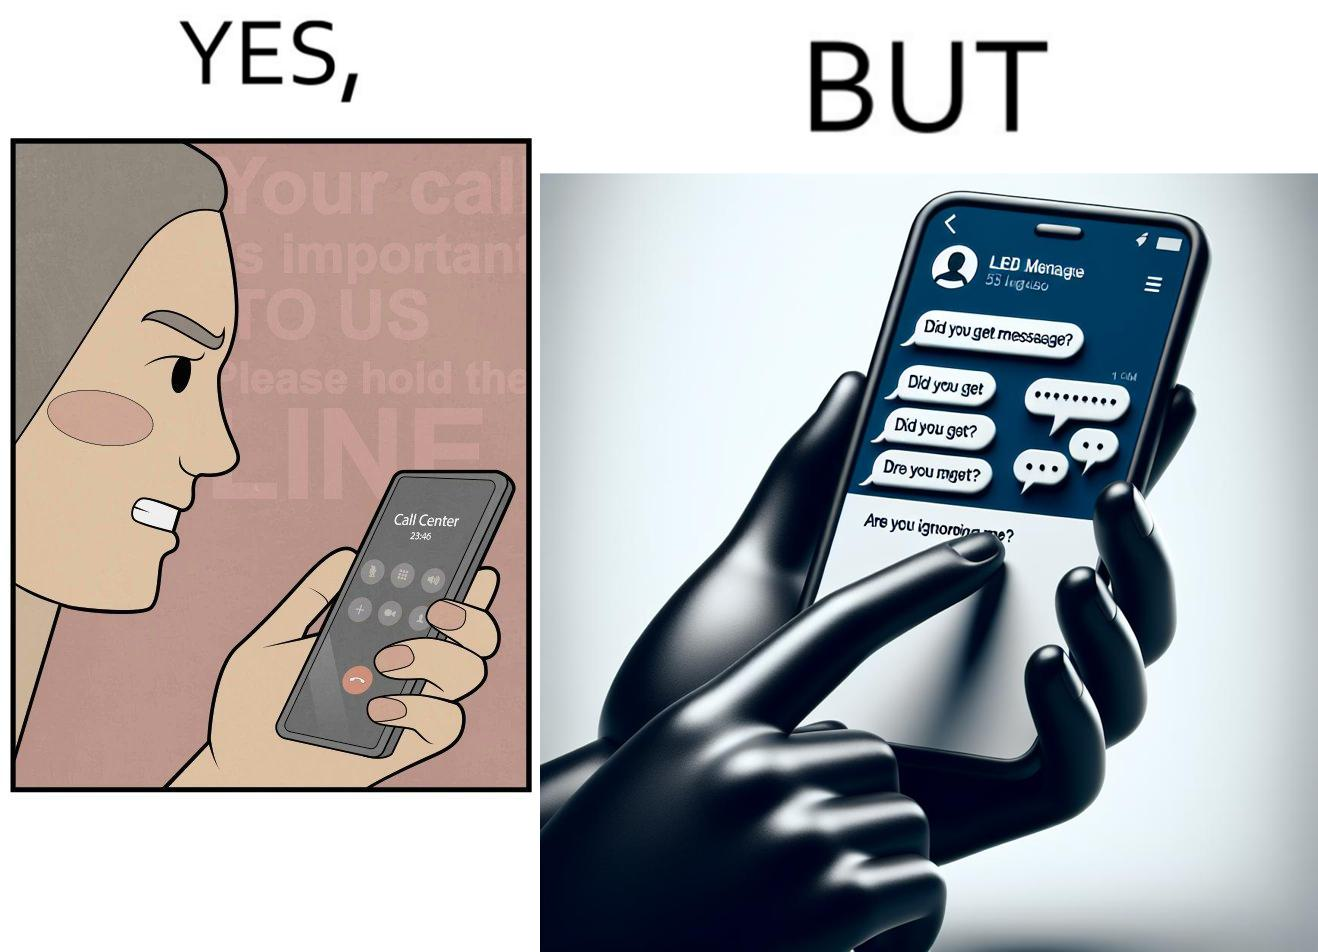What makes this image funny or satirical? The image is ironical because while the woman is annoyed by the unresponsiveness of the call center, she herself is being unresponsive to many people in the chat. 